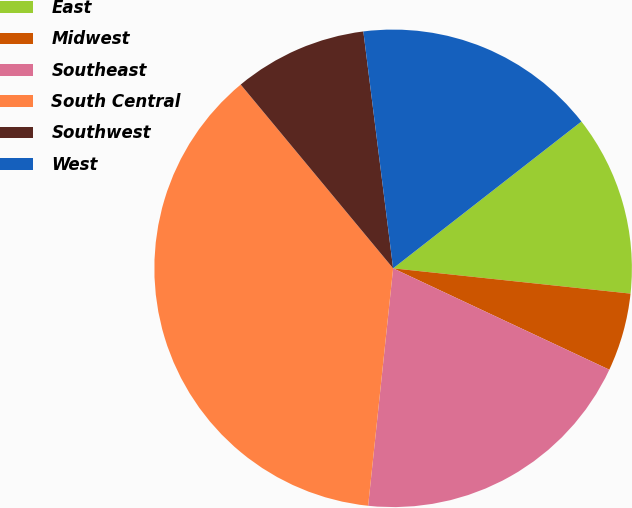Convert chart. <chart><loc_0><loc_0><loc_500><loc_500><pie_chart><fcel>East<fcel>Midwest<fcel>Southeast<fcel>South Central<fcel>Southwest<fcel>West<nl><fcel>12.23%<fcel>5.29%<fcel>19.69%<fcel>37.31%<fcel>9.03%<fcel>16.45%<nl></chart> 